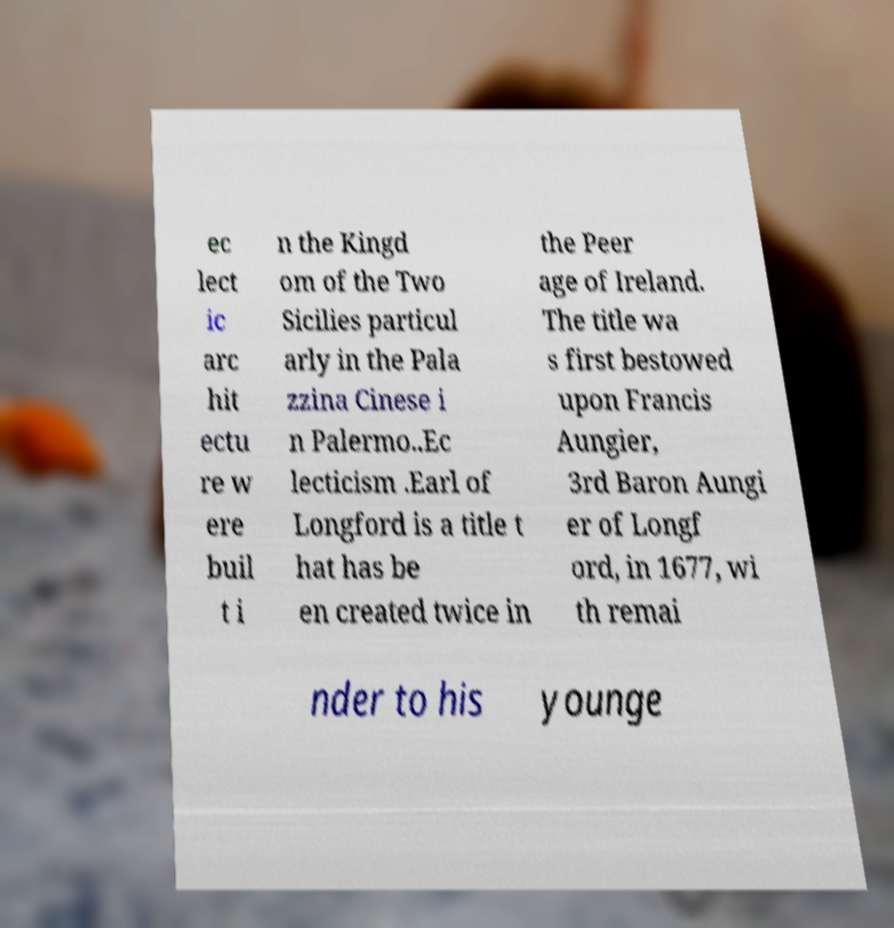For documentation purposes, I need the text within this image transcribed. Could you provide that? ec lect ic arc hit ectu re w ere buil t i n the Kingd om of the Two Sicilies particul arly in the Pala zzina Cinese i n Palermo..Ec lecticism .Earl of Longford is a title t hat has be en created twice in the Peer age of Ireland. The title wa s first bestowed upon Francis Aungier, 3rd Baron Aungi er of Longf ord, in 1677, wi th remai nder to his younge 